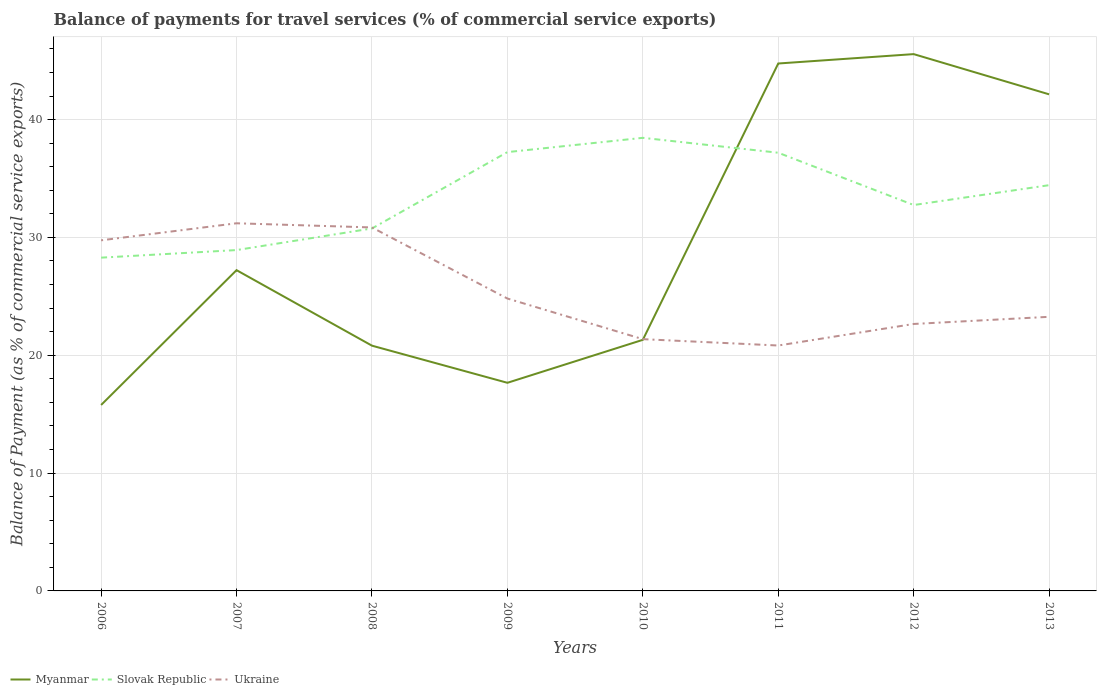Is the number of lines equal to the number of legend labels?
Offer a very short reply. Yes. Across all years, what is the maximum balance of payments for travel services in Myanmar?
Your answer should be very brief. 15.78. In which year was the balance of payments for travel services in Ukraine maximum?
Provide a succinct answer. 2011. What is the total balance of payments for travel services in Slovak Republic in the graph?
Your answer should be compact. -8.96. What is the difference between the highest and the second highest balance of payments for travel services in Myanmar?
Provide a succinct answer. 29.78. Is the balance of payments for travel services in Slovak Republic strictly greater than the balance of payments for travel services in Myanmar over the years?
Offer a very short reply. No. Are the values on the major ticks of Y-axis written in scientific E-notation?
Your answer should be very brief. No. Does the graph contain any zero values?
Give a very brief answer. No. Does the graph contain grids?
Make the answer very short. Yes. Where does the legend appear in the graph?
Give a very brief answer. Bottom left. How are the legend labels stacked?
Your answer should be compact. Horizontal. What is the title of the graph?
Ensure brevity in your answer.  Balance of payments for travel services (% of commercial service exports). What is the label or title of the X-axis?
Provide a short and direct response. Years. What is the label or title of the Y-axis?
Ensure brevity in your answer.  Balance of Payment (as % of commercial service exports). What is the Balance of Payment (as % of commercial service exports) in Myanmar in 2006?
Make the answer very short. 15.78. What is the Balance of Payment (as % of commercial service exports) of Slovak Republic in 2006?
Your response must be concise. 28.28. What is the Balance of Payment (as % of commercial service exports) of Ukraine in 2006?
Ensure brevity in your answer.  29.75. What is the Balance of Payment (as % of commercial service exports) of Myanmar in 2007?
Your response must be concise. 27.22. What is the Balance of Payment (as % of commercial service exports) in Slovak Republic in 2007?
Your answer should be compact. 28.93. What is the Balance of Payment (as % of commercial service exports) of Ukraine in 2007?
Give a very brief answer. 31.2. What is the Balance of Payment (as % of commercial service exports) in Myanmar in 2008?
Make the answer very short. 20.81. What is the Balance of Payment (as % of commercial service exports) in Slovak Republic in 2008?
Your answer should be compact. 30.76. What is the Balance of Payment (as % of commercial service exports) in Ukraine in 2008?
Provide a short and direct response. 30.85. What is the Balance of Payment (as % of commercial service exports) in Myanmar in 2009?
Make the answer very short. 17.66. What is the Balance of Payment (as % of commercial service exports) of Slovak Republic in 2009?
Provide a succinct answer. 37.24. What is the Balance of Payment (as % of commercial service exports) in Ukraine in 2009?
Provide a succinct answer. 24.81. What is the Balance of Payment (as % of commercial service exports) of Myanmar in 2010?
Your response must be concise. 21.31. What is the Balance of Payment (as % of commercial service exports) of Slovak Republic in 2010?
Give a very brief answer. 38.45. What is the Balance of Payment (as % of commercial service exports) of Ukraine in 2010?
Keep it short and to the point. 21.37. What is the Balance of Payment (as % of commercial service exports) of Myanmar in 2011?
Give a very brief answer. 44.76. What is the Balance of Payment (as % of commercial service exports) of Slovak Republic in 2011?
Give a very brief answer. 37.19. What is the Balance of Payment (as % of commercial service exports) in Ukraine in 2011?
Provide a short and direct response. 20.83. What is the Balance of Payment (as % of commercial service exports) in Myanmar in 2012?
Your answer should be very brief. 45.56. What is the Balance of Payment (as % of commercial service exports) of Slovak Republic in 2012?
Make the answer very short. 32.75. What is the Balance of Payment (as % of commercial service exports) of Ukraine in 2012?
Your answer should be compact. 22.65. What is the Balance of Payment (as % of commercial service exports) of Myanmar in 2013?
Give a very brief answer. 42.14. What is the Balance of Payment (as % of commercial service exports) of Slovak Republic in 2013?
Your answer should be very brief. 34.43. What is the Balance of Payment (as % of commercial service exports) of Ukraine in 2013?
Your answer should be very brief. 23.26. Across all years, what is the maximum Balance of Payment (as % of commercial service exports) of Myanmar?
Ensure brevity in your answer.  45.56. Across all years, what is the maximum Balance of Payment (as % of commercial service exports) of Slovak Republic?
Provide a succinct answer. 38.45. Across all years, what is the maximum Balance of Payment (as % of commercial service exports) in Ukraine?
Offer a terse response. 31.2. Across all years, what is the minimum Balance of Payment (as % of commercial service exports) in Myanmar?
Ensure brevity in your answer.  15.78. Across all years, what is the minimum Balance of Payment (as % of commercial service exports) of Slovak Republic?
Provide a short and direct response. 28.28. Across all years, what is the minimum Balance of Payment (as % of commercial service exports) in Ukraine?
Ensure brevity in your answer.  20.83. What is the total Balance of Payment (as % of commercial service exports) in Myanmar in the graph?
Make the answer very short. 235.24. What is the total Balance of Payment (as % of commercial service exports) in Slovak Republic in the graph?
Offer a very short reply. 268.03. What is the total Balance of Payment (as % of commercial service exports) in Ukraine in the graph?
Keep it short and to the point. 204.72. What is the difference between the Balance of Payment (as % of commercial service exports) of Myanmar in 2006 and that in 2007?
Your answer should be very brief. -11.44. What is the difference between the Balance of Payment (as % of commercial service exports) in Slovak Republic in 2006 and that in 2007?
Your answer should be very brief. -0.64. What is the difference between the Balance of Payment (as % of commercial service exports) of Ukraine in 2006 and that in 2007?
Ensure brevity in your answer.  -1.45. What is the difference between the Balance of Payment (as % of commercial service exports) in Myanmar in 2006 and that in 2008?
Keep it short and to the point. -5.03. What is the difference between the Balance of Payment (as % of commercial service exports) in Slovak Republic in 2006 and that in 2008?
Give a very brief answer. -2.48. What is the difference between the Balance of Payment (as % of commercial service exports) of Ukraine in 2006 and that in 2008?
Keep it short and to the point. -1.09. What is the difference between the Balance of Payment (as % of commercial service exports) of Myanmar in 2006 and that in 2009?
Make the answer very short. -1.88. What is the difference between the Balance of Payment (as % of commercial service exports) of Slovak Republic in 2006 and that in 2009?
Make the answer very short. -8.96. What is the difference between the Balance of Payment (as % of commercial service exports) in Ukraine in 2006 and that in 2009?
Give a very brief answer. 4.94. What is the difference between the Balance of Payment (as % of commercial service exports) of Myanmar in 2006 and that in 2010?
Provide a short and direct response. -5.53. What is the difference between the Balance of Payment (as % of commercial service exports) in Slovak Republic in 2006 and that in 2010?
Your answer should be very brief. -10.17. What is the difference between the Balance of Payment (as % of commercial service exports) in Ukraine in 2006 and that in 2010?
Your answer should be very brief. 8.39. What is the difference between the Balance of Payment (as % of commercial service exports) in Myanmar in 2006 and that in 2011?
Offer a very short reply. -28.98. What is the difference between the Balance of Payment (as % of commercial service exports) in Slovak Republic in 2006 and that in 2011?
Your answer should be compact. -8.9. What is the difference between the Balance of Payment (as % of commercial service exports) in Ukraine in 2006 and that in 2011?
Your answer should be very brief. 8.93. What is the difference between the Balance of Payment (as % of commercial service exports) of Myanmar in 2006 and that in 2012?
Provide a short and direct response. -29.78. What is the difference between the Balance of Payment (as % of commercial service exports) of Slovak Republic in 2006 and that in 2012?
Provide a short and direct response. -4.47. What is the difference between the Balance of Payment (as % of commercial service exports) of Ukraine in 2006 and that in 2012?
Give a very brief answer. 7.1. What is the difference between the Balance of Payment (as % of commercial service exports) in Myanmar in 2006 and that in 2013?
Your answer should be very brief. -26.36. What is the difference between the Balance of Payment (as % of commercial service exports) in Slovak Republic in 2006 and that in 2013?
Your answer should be compact. -6.15. What is the difference between the Balance of Payment (as % of commercial service exports) of Ukraine in 2006 and that in 2013?
Provide a succinct answer. 6.49. What is the difference between the Balance of Payment (as % of commercial service exports) of Myanmar in 2007 and that in 2008?
Provide a succinct answer. 6.41. What is the difference between the Balance of Payment (as % of commercial service exports) of Slovak Republic in 2007 and that in 2008?
Your answer should be compact. -1.83. What is the difference between the Balance of Payment (as % of commercial service exports) in Ukraine in 2007 and that in 2008?
Offer a terse response. 0.35. What is the difference between the Balance of Payment (as % of commercial service exports) of Myanmar in 2007 and that in 2009?
Your response must be concise. 9.56. What is the difference between the Balance of Payment (as % of commercial service exports) of Slovak Republic in 2007 and that in 2009?
Offer a very short reply. -8.31. What is the difference between the Balance of Payment (as % of commercial service exports) of Ukraine in 2007 and that in 2009?
Provide a succinct answer. 6.39. What is the difference between the Balance of Payment (as % of commercial service exports) of Myanmar in 2007 and that in 2010?
Make the answer very short. 5.91. What is the difference between the Balance of Payment (as % of commercial service exports) of Slovak Republic in 2007 and that in 2010?
Give a very brief answer. -9.53. What is the difference between the Balance of Payment (as % of commercial service exports) of Ukraine in 2007 and that in 2010?
Keep it short and to the point. 9.83. What is the difference between the Balance of Payment (as % of commercial service exports) of Myanmar in 2007 and that in 2011?
Provide a short and direct response. -17.54. What is the difference between the Balance of Payment (as % of commercial service exports) of Slovak Republic in 2007 and that in 2011?
Your answer should be very brief. -8.26. What is the difference between the Balance of Payment (as % of commercial service exports) in Ukraine in 2007 and that in 2011?
Ensure brevity in your answer.  10.37. What is the difference between the Balance of Payment (as % of commercial service exports) in Myanmar in 2007 and that in 2012?
Your answer should be compact. -18.33. What is the difference between the Balance of Payment (as % of commercial service exports) of Slovak Republic in 2007 and that in 2012?
Offer a terse response. -3.82. What is the difference between the Balance of Payment (as % of commercial service exports) of Ukraine in 2007 and that in 2012?
Provide a succinct answer. 8.55. What is the difference between the Balance of Payment (as % of commercial service exports) in Myanmar in 2007 and that in 2013?
Provide a succinct answer. -14.92. What is the difference between the Balance of Payment (as % of commercial service exports) of Slovak Republic in 2007 and that in 2013?
Keep it short and to the point. -5.51. What is the difference between the Balance of Payment (as % of commercial service exports) of Ukraine in 2007 and that in 2013?
Offer a terse response. 7.94. What is the difference between the Balance of Payment (as % of commercial service exports) of Myanmar in 2008 and that in 2009?
Ensure brevity in your answer.  3.15. What is the difference between the Balance of Payment (as % of commercial service exports) of Slovak Republic in 2008 and that in 2009?
Your response must be concise. -6.48. What is the difference between the Balance of Payment (as % of commercial service exports) in Ukraine in 2008 and that in 2009?
Ensure brevity in your answer.  6.03. What is the difference between the Balance of Payment (as % of commercial service exports) in Myanmar in 2008 and that in 2010?
Keep it short and to the point. -0.49. What is the difference between the Balance of Payment (as % of commercial service exports) of Slovak Republic in 2008 and that in 2010?
Offer a terse response. -7.69. What is the difference between the Balance of Payment (as % of commercial service exports) in Ukraine in 2008 and that in 2010?
Make the answer very short. 9.48. What is the difference between the Balance of Payment (as % of commercial service exports) of Myanmar in 2008 and that in 2011?
Keep it short and to the point. -23.95. What is the difference between the Balance of Payment (as % of commercial service exports) in Slovak Republic in 2008 and that in 2011?
Your response must be concise. -6.43. What is the difference between the Balance of Payment (as % of commercial service exports) in Ukraine in 2008 and that in 2011?
Your answer should be very brief. 10.02. What is the difference between the Balance of Payment (as % of commercial service exports) of Myanmar in 2008 and that in 2012?
Your response must be concise. -24.74. What is the difference between the Balance of Payment (as % of commercial service exports) of Slovak Republic in 2008 and that in 2012?
Give a very brief answer. -1.99. What is the difference between the Balance of Payment (as % of commercial service exports) in Ukraine in 2008 and that in 2012?
Ensure brevity in your answer.  8.19. What is the difference between the Balance of Payment (as % of commercial service exports) of Myanmar in 2008 and that in 2013?
Your response must be concise. -21.33. What is the difference between the Balance of Payment (as % of commercial service exports) of Slovak Republic in 2008 and that in 2013?
Offer a very short reply. -3.67. What is the difference between the Balance of Payment (as % of commercial service exports) in Ukraine in 2008 and that in 2013?
Give a very brief answer. 7.58. What is the difference between the Balance of Payment (as % of commercial service exports) of Myanmar in 2009 and that in 2010?
Give a very brief answer. -3.64. What is the difference between the Balance of Payment (as % of commercial service exports) in Slovak Republic in 2009 and that in 2010?
Your response must be concise. -1.21. What is the difference between the Balance of Payment (as % of commercial service exports) of Ukraine in 2009 and that in 2010?
Provide a short and direct response. 3.45. What is the difference between the Balance of Payment (as % of commercial service exports) in Myanmar in 2009 and that in 2011?
Give a very brief answer. -27.1. What is the difference between the Balance of Payment (as % of commercial service exports) of Slovak Republic in 2009 and that in 2011?
Your answer should be very brief. 0.05. What is the difference between the Balance of Payment (as % of commercial service exports) in Ukraine in 2009 and that in 2011?
Ensure brevity in your answer.  3.99. What is the difference between the Balance of Payment (as % of commercial service exports) in Myanmar in 2009 and that in 2012?
Your response must be concise. -27.89. What is the difference between the Balance of Payment (as % of commercial service exports) in Slovak Republic in 2009 and that in 2012?
Offer a terse response. 4.49. What is the difference between the Balance of Payment (as % of commercial service exports) in Ukraine in 2009 and that in 2012?
Provide a succinct answer. 2.16. What is the difference between the Balance of Payment (as % of commercial service exports) of Myanmar in 2009 and that in 2013?
Keep it short and to the point. -24.48. What is the difference between the Balance of Payment (as % of commercial service exports) of Slovak Republic in 2009 and that in 2013?
Provide a succinct answer. 2.81. What is the difference between the Balance of Payment (as % of commercial service exports) in Ukraine in 2009 and that in 2013?
Your response must be concise. 1.55. What is the difference between the Balance of Payment (as % of commercial service exports) of Myanmar in 2010 and that in 2011?
Provide a succinct answer. -23.45. What is the difference between the Balance of Payment (as % of commercial service exports) of Slovak Republic in 2010 and that in 2011?
Your answer should be very brief. 1.26. What is the difference between the Balance of Payment (as % of commercial service exports) in Ukraine in 2010 and that in 2011?
Make the answer very short. 0.54. What is the difference between the Balance of Payment (as % of commercial service exports) of Myanmar in 2010 and that in 2012?
Your answer should be compact. -24.25. What is the difference between the Balance of Payment (as % of commercial service exports) in Slovak Republic in 2010 and that in 2012?
Your answer should be compact. 5.7. What is the difference between the Balance of Payment (as % of commercial service exports) in Ukraine in 2010 and that in 2012?
Offer a very short reply. -1.29. What is the difference between the Balance of Payment (as % of commercial service exports) in Myanmar in 2010 and that in 2013?
Offer a very short reply. -20.84. What is the difference between the Balance of Payment (as % of commercial service exports) of Slovak Republic in 2010 and that in 2013?
Offer a very short reply. 4.02. What is the difference between the Balance of Payment (as % of commercial service exports) in Ukraine in 2010 and that in 2013?
Make the answer very short. -1.9. What is the difference between the Balance of Payment (as % of commercial service exports) of Myanmar in 2011 and that in 2012?
Your response must be concise. -0.8. What is the difference between the Balance of Payment (as % of commercial service exports) of Slovak Republic in 2011 and that in 2012?
Your response must be concise. 4.44. What is the difference between the Balance of Payment (as % of commercial service exports) in Ukraine in 2011 and that in 2012?
Your answer should be very brief. -1.83. What is the difference between the Balance of Payment (as % of commercial service exports) in Myanmar in 2011 and that in 2013?
Provide a succinct answer. 2.62. What is the difference between the Balance of Payment (as % of commercial service exports) in Slovak Republic in 2011 and that in 2013?
Make the answer very short. 2.75. What is the difference between the Balance of Payment (as % of commercial service exports) of Ukraine in 2011 and that in 2013?
Your answer should be compact. -2.44. What is the difference between the Balance of Payment (as % of commercial service exports) of Myanmar in 2012 and that in 2013?
Ensure brevity in your answer.  3.41. What is the difference between the Balance of Payment (as % of commercial service exports) of Slovak Republic in 2012 and that in 2013?
Provide a succinct answer. -1.68. What is the difference between the Balance of Payment (as % of commercial service exports) in Ukraine in 2012 and that in 2013?
Make the answer very short. -0.61. What is the difference between the Balance of Payment (as % of commercial service exports) of Myanmar in 2006 and the Balance of Payment (as % of commercial service exports) of Slovak Republic in 2007?
Keep it short and to the point. -13.15. What is the difference between the Balance of Payment (as % of commercial service exports) of Myanmar in 2006 and the Balance of Payment (as % of commercial service exports) of Ukraine in 2007?
Provide a short and direct response. -15.42. What is the difference between the Balance of Payment (as % of commercial service exports) in Slovak Republic in 2006 and the Balance of Payment (as % of commercial service exports) in Ukraine in 2007?
Ensure brevity in your answer.  -2.92. What is the difference between the Balance of Payment (as % of commercial service exports) in Myanmar in 2006 and the Balance of Payment (as % of commercial service exports) in Slovak Republic in 2008?
Keep it short and to the point. -14.98. What is the difference between the Balance of Payment (as % of commercial service exports) of Myanmar in 2006 and the Balance of Payment (as % of commercial service exports) of Ukraine in 2008?
Offer a very short reply. -15.07. What is the difference between the Balance of Payment (as % of commercial service exports) in Slovak Republic in 2006 and the Balance of Payment (as % of commercial service exports) in Ukraine in 2008?
Your answer should be very brief. -2.56. What is the difference between the Balance of Payment (as % of commercial service exports) in Myanmar in 2006 and the Balance of Payment (as % of commercial service exports) in Slovak Republic in 2009?
Your response must be concise. -21.46. What is the difference between the Balance of Payment (as % of commercial service exports) of Myanmar in 2006 and the Balance of Payment (as % of commercial service exports) of Ukraine in 2009?
Your answer should be very brief. -9.04. What is the difference between the Balance of Payment (as % of commercial service exports) in Slovak Republic in 2006 and the Balance of Payment (as % of commercial service exports) in Ukraine in 2009?
Your response must be concise. 3.47. What is the difference between the Balance of Payment (as % of commercial service exports) of Myanmar in 2006 and the Balance of Payment (as % of commercial service exports) of Slovak Republic in 2010?
Your answer should be very brief. -22.67. What is the difference between the Balance of Payment (as % of commercial service exports) of Myanmar in 2006 and the Balance of Payment (as % of commercial service exports) of Ukraine in 2010?
Your response must be concise. -5.59. What is the difference between the Balance of Payment (as % of commercial service exports) of Slovak Republic in 2006 and the Balance of Payment (as % of commercial service exports) of Ukraine in 2010?
Provide a succinct answer. 6.92. What is the difference between the Balance of Payment (as % of commercial service exports) of Myanmar in 2006 and the Balance of Payment (as % of commercial service exports) of Slovak Republic in 2011?
Keep it short and to the point. -21.41. What is the difference between the Balance of Payment (as % of commercial service exports) of Myanmar in 2006 and the Balance of Payment (as % of commercial service exports) of Ukraine in 2011?
Your response must be concise. -5.05. What is the difference between the Balance of Payment (as % of commercial service exports) of Slovak Republic in 2006 and the Balance of Payment (as % of commercial service exports) of Ukraine in 2011?
Provide a short and direct response. 7.46. What is the difference between the Balance of Payment (as % of commercial service exports) of Myanmar in 2006 and the Balance of Payment (as % of commercial service exports) of Slovak Republic in 2012?
Your answer should be compact. -16.97. What is the difference between the Balance of Payment (as % of commercial service exports) of Myanmar in 2006 and the Balance of Payment (as % of commercial service exports) of Ukraine in 2012?
Your answer should be compact. -6.88. What is the difference between the Balance of Payment (as % of commercial service exports) in Slovak Republic in 2006 and the Balance of Payment (as % of commercial service exports) in Ukraine in 2012?
Your answer should be compact. 5.63. What is the difference between the Balance of Payment (as % of commercial service exports) in Myanmar in 2006 and the Balance of Payment (as % of commercial service exports) in Slovak Republic in 2013?
Provide a succinct answer. -18.65. What is the difference between the Balance of Payment (as % of commercial service exports) of Myanmar in 2006 and the Balance of Payment (as % of commercial service exports) of Ukraine in 2013?
Your answer should be very brief. -7.48. What is the difference between the Balance of Payment (as % of commercial service exports) in Slovak Republic in 2006 and the Balance of Payment (as % of commercial service exports) in Ukraine in 2013?
Ensure brevity in your answer.  5.02. What is the difference between the Balance of Payment (as % of commercial service exports) in Myanmar in 2007 and the Balance of Payment (as % of commercial service exports) in Slovak Republic in 2008?
Make the answer very short. -3.54. What is the difference between the Balance of Payment (as % of commercial service exports) of Myanmar in 2007 and the Balance of Payment (as % of commercial service exports) of Ukraine in 2008?
Give a very brief answer. -3.63. What is the difference between the Balance of Payment (as % of commercial service exports) of Slovak Republic in 2007 and the Balance of Payment (as % of commercial service exports) of Ukraine in 2008?
Make the answer very short. -1.92. What is the difference between the Balance of Payment (as % of commercial service exports) of Myanmar in 2007 and the Balance of Payment (as % of commercial service exports) of Slovak Republic in 2009?
Make the answer very short. -10.02. What is the difference between the Balance of Payment (as % of commercial service exports) in Myanmar in 2007 and the Balance of Payment (as % of commercial service exports) in Ukraine in 2009?
Offer a terse response. 2.41. What is the difference between the Balance of Payment (as % of commercial service exports) in Slovak Republic in 2007 and the Balance of Payment (as % of commercial service exports) in Ukraine in 2009?
Offer a terse response. 4.11. What is the difference between the Balance of Payment (as % of commercial service exports) in Myanmar in 2007 and the Balance of Payment (as % of commercial service exports) in Slovak Republic in 2010?
Your response must be concise. -11.23. What is the difference between the Balance of Payment (as % of commercial service exports) of Myanmar in 2007 and the Balance of Payment (as % of commercial service exports) of Ukraine in 2010?
Make the answer very short. 5.86. What is the difference between the Balance of Payment (as % of commercial service exports) of Slovak Republic in 2007 and the Balance of Payment (as % of commercial service exports) of Ukraine in 2010?
Your response must be concise. 7.56. What is the difference between the Balance of Payment (as % of commercial service exports) in Myanmar in 2007 and the Balance of Payment (as % of commercial service exports) in Slovak Republic in 2011?
Offer a terse response. -9.97. What is the difference between the Balance of Payment (as % of commercial service exports) of Myanmar in 2007 and the Balance of Payment (as % of commercial service exports) of Ukraine in 2011?
Keep it short and to the point. 6.39. What is the difference between the Balance of Payment (as % of commercial service exports) of Slovak Republic in 2007 and the Balance of Payment (as % of commercial service exports) of Ukraine in 2011?
Give a very brief answer. 8.1. What is the difference between the Balance of Payment (as % of commercial service exports) in Myanmar in 2007 and the Balance of Payment (as % of commercial service exports) in Slovak Republic in 2012?
Give a very brief answer. -5.53. What is the difference between the Balance of Payment (as % of commercial service exports) in Myanmar in 2007 and the Balance of Payment (as % of commercial service exports) in Ukraine in 2012?
Offer a very short reply. 4.57. What is the difference between the Balance of Payment (as % of commercial service exports) in Slovak Republic in 2007 and the Balance of Payment (as % of commercial service exports) in Ukraine in 2012?
Provide a short and direct response. 6.27. What is the difference between the Balance of Payment (as % of commercial service exports) of Myanmar in 2007 and the Balance of Payment (as % of commercial service exports) of Slovak Republic in 2013?
Keep it short and to the point. -7.21. What is the difference between the Balance of Payment (as % of commercial service exports) of Myanmar in 2007 and the Balance of Payment (as % of commercial service exports) of Ukraine in 2013?
Your response must be concise. 3.96. What is the difference between the Balance of Payment (as % of commercial service exports) in Slovak Republic in 2007 and the Balance of Payment (as % of commercial service exports) in Ukraine in 2013?
Provide a succinct answer. 5.66. What is the difference between the Balance of Payment (as % of commercial service exports) in Myanmar in 2008 and the Balance of Payment (as % of commercial service exports) in Slovak Republic in 2009?
Give a very brief answer. -16.43. What is the difference between the Balance of Payment (as % of commercial service exports) in Myanmar in 2008 and the Balance of Payment (as % of commercial service exports) in Ukraine in 2009?
Provide a succinct answer. -4. What is the difference between the Balance of Payment (as % of commercial service exports) of Slovak Republic in 2008 and the Balance of Payment (as % of commercial service exports) of Ukraine in 2009?
Make the answer very short. 5.95. What is the difference between the Balance of Payment (as % of commercial service exports) of Myanmar in 2008 and the Balance of Payment (as % of commercial service exports) of Slovak Republic in 2010?
Provide a succinct answer. -17.64. What is the difference between the Balance of Payment (as % of commercial service exports) in Myanmar in 2008 and the Balance of Payment (as % of commercial service exports) in Ukraine in 2010?
Your response must be concise. -0.55. What is the difference between the Balance of Payment (as % of commercial service exports) in Slovak Republic in 2008 and the Balance of Payment (as % of commercial service exports) in Ukraine in 2010?
Give a very brief answer. 9.39. What is the difference between the Balance of Payment (as % of commercial service exports) of Myanmar in 2008 and the Balance of Payment (as % of commercial service exports) of Slovak Republic in 2011?
Provide a succinct answer. -16.37. What is the difference between the Balance of Payment (as % of commercial service exports) in Myanmar in 2008 and the Balance of Payment (as % of commercial service exports) in Ukraine in 2011?
Your answer should be very brief. -0.01. What is the difference between the Balance of Payment (as % of commercial service exports) of Slovak Republic in 2008 and the Balance of Payment (as % of commercial service exports) of Ukraine in 2011?
Provide a short and direct response. 9.93. What is the difference between the Balance of Payment (as % of commercial service exports) of Myanmar in 2008 and the Balance of Payment (as % of commercial service exports) of Slovak Republic in 2012?
Make the answer very short. -11.94. What is the difference between the Balance of Payment (as % of commercial service exports) of Myanmar in 2008 and the Balance of Payment (as % of commercial service exports) of Ukraine in 2012?
Your answer should be compact. -1.84. What is the difference between the Balance of Payment (as % of commercial service exports) of Slovak Republic in 2008 and the Balance of Payment (as % of commercial service exports) of Ukraine in 2012?
Keep it short and to the point. 8.1. What is the difference between the Balance of Payment (as % of commercial service exports) in Myanmar in 2008 and the Balance of Payment (as % of commercial service exports) in Slovak Republic in 2013?
Provide a short and direct response. -13.62. What is the difference between the Balance of Payment (as % of commercial service exports) of Myanmar in 2008 and the Balance of Payment (as % of commercial service exports) of Ukraine in 2013?
Your response must be concise. -2.45. What is the difference between the Balance of Payment (as % of commercial service exports) in Slovak Republic in 2008 and the Balance of Payment (as % of commercial service exports) in Ukraine in 2013?
Provide a short and direct response. 7.5. What is the difference between the Balance of Payment (as % of commercial service exports) in Myanmar in 2009 and the Balance of Payment (as % of commercial service exports) in Slovak Republic in 2010?
Your answer should be very brief. -20.79. What is the difference between the Balance of Payment (as % of commercial service exports) in Myanmar in 2009 and the Balance of Payment (as % of commercial service exports) in Ukraine in 2010?
Offer a terse response. -3.7. What is the difference between the Balance of Payment (as % of commercial service exports) of Slovak Republic in 2009 and the Balance of Payment (as % of commercial service exports) of Ukraine in 2010?
Your response must be concise. 15.87. What is the difference between the Balance of Payment (as % of commercial service exports) in Myanmar in 2009 and the Balance of Payment (as % of commercial service exports) in Slovak Republic in 2011?
Ensure brevity in your answer.  -19.52. What is the difference between the Balance of Payment (as % of commercial service exports) of Myanmar in 2009 and the Balance of Payment (as % of commercial service exports) of Ukraine in 2011?
Your answer should be very brief. -3.16. What is the difference between the Balance of Payment (as % of commercial service exports) in Slovak Republic in 2009 and the Balance of Payment (as % of commercial service exports) in Ukraine in 2011?
Provide a short and direct response. 16.41. What is the difference between the Balance of Payment (as % of commercial service exports) in Myanmar in 2009 and the Balance of Payment (as % of commercial service exports) in Slovak Republic in 2012?
Your answer should be very brief. -15.09. What is the difference between the Balance of Payment (as % of commercial service exports) in Myanmar in 2009 and the Balance of Payment (as % of commercial service exports) in Ukraine in 2012?
Keep it short and to the point. -4.99. What is the difference between the Balance of Payment (as % of commercial service exports) in Slovak Republic in 2009 and the Balance of Payment (as % of commercial service exports) in Ukraine in 2012?
Your response must be concise. 14.59. What is the difference between the Balance of Payment (as % of commercial service exports) in Myanmar in 2009 and the Balance of Payment (as % of commercial service exports) in Slovak Republic in 2013?
Your answer should be very brief. -16.77. What is the difference between the Balance of Payment (as % of commercial service exports) of Myanmar in 2009 and the Balance of Payment (as % of commercial service exports) of Ukraine in 2013?
Give a very brief answer. -5.6. What is the difference between the Balance of Payment (as % of commercial service exports) in Slovak Republic in 2009 and the Balance of Payment (as % of commercial service exports) in Ukraine in 2013?
Ensure brevity in your answer.  13.98. What is the difference between the Balance of Payment (as % of commercial service exports) of Myanmar in 2010 and the Balance of Payment (as % of commercial service exports) of Slovak Republic in 2011?
Your answer should be compact. -15.88. What is the difference between the Balance of Payment (as % of commercial service exports) of Myanmar in 2010 and the Balance of Payment (as % of commercial service exports) of Ukraine in 2011?
Provide a succinct answer. 0.48. What is the difference between the Balance of Payment (as % of commercial service exports) of Slovak Republic in 2010 and the Balance of Payment (as % of commercial service exports) of Ukraine in 2011?
Your response must be concise. 17.63. What is the difference between the Balance of Payment (as % of commercial service exports) of Myanmar in 2010 and the Balance of Payment (as % of commercial service exports) of Slovak Republic in 2012?
Give a very brief answer. -11.44. What is the difference between the Balance of Payment (as % of commercial service exports) of Myanmar in 2010 and the Balance of Payment (as % of commercial service exports) of Ukraine in 2012?
Make the answer very short. -1.35. What is the difference between the Balance of Payment (as % of commercial service exports) of Slovak Republic in 2010 and the Balance of Payment (as % of commercial service exports) of Ukraine in 2012?
Offer a terse response. 15.8. What is the difference between the Balance of Payment (as % of commercial service exports) in Myanmar in 2010 and the Balance of Payment (as % of commercial service exports) in Slovak Republic in 2013?
Offer a very short reply. -13.13. What is the difference between the Balance of Payment (as % of commercial service exports) of Myanmar in 2010 and the Balance of Payment (as % of commercial service exports) of Ukraine in 2013?
Your response must be concise. -1.95. What is the difference between the Balance of Payment (as % of commercial service exports) in Slovak Republic in 2010 and the Balance of Payment (as % of commercial service exports) in Ukraine in 2013?
Provide a short and direct response. 15.19. What is the difference between the Balance of Payment (as % of commercial service exports) of Myanmar in 2011 and the Balance of Payment (as % of commercial service exports) of Slovak Republic in 2012?
Make the answer very short. 12.01. What is the difference between the Balance of Payment (as % of commercial service exports) in Myanmar in 2011 and the Balance of Payment (as % of commercial service exports) in Ukraine in 2012?
Provide a succinct answer. 22.11. What is the difference between the Balance of Payment (as % of commercial service exports) in Slovak Republic in 2011 and the Balance of Payment (as % of commercial service exports) in Ukraine in 2012?
Offer a terse response. 14.53. What is the difference between the Balance of Payment (as % of commercial service exports) in Myanmar in 2011 and the Balance of Payment (as % of commercial service exports) in Slovak Republic in 2013?
Give a very brief answer. 10.33. What is the difference between the Balance of Payment (as % of commercial service exports) of Myanmar in 2011 and the Balance of Payment (as % of commercial service exports) of Ukraine in 2013?
Make the answer very short. 21.5. What is the difference between the Balance of Payment (as % of commercial service exports) in Slovak Republic in 2011 and the Balance of Payment (as % of commercial service exports) in Ukraine in 2013?
Give a very brief answer. 13.92. What is the difference between the Balance of Payment (as % of commercial service exports) of Myanmar in 2012 and the Balance of Payment (as % of commercial service exports) of Slovak Republic in 2013?
Your answer should be very brief. 11.12. What is the difference between the Balance of Payment (as % of commercial service exports) in Myanmar in 2012 and the Balance of Payment (as % of commercial service exports) in Ukraine in 2013?
Offer a very short reply. 22.29. What is the difference between the Balance of Payment (as % of commercial service exports) in Slovak Republic in 2012 and the Balance of Payment (as % of commercial service exports) in Ukraine in 2013?
Keep it short and to the point. 9.49. What is the average Balance of Payment (as % of commercial service exports) in Myanmar per year?
Offer a very short reply. 29.41. What is the average Balance of Payment (as % of commercial service exports) of Slovak Republic per year?
Offer a terse response. 33.5. What is the average Balance of Payment (as % of commercial service exports) of Ukraine per year?
Keep it short and to the point. 25.59. In the year 2006, what is the difference between the Balance of Payment (as % of commercial service exports) in Myanmar and Balance of Payment (as % of commercial service exports) in Slovak Republic?
Make the answer very short. -12.5. In the year 2006, what is the difference between the Balance of Payment (as % of commercial service exports) in Myanmar and Balance of Payment (as % of commercial service exports) in Ukraine?
Make the answer very short. -13.97. In the year 2006, what is the difference between the Balance of Payment (as % of commercial service exports) in Slovak Republic and Balance of Payment (as % of commercial service exports) in Ukraine?
Offer a terse response. -1.47. In the year 2007, what is the difference between the Balance of Payment (as % of commercial service exports) in Myanmar and Balance of Payment (as % of commercial service exports) in Slovak Republic?
Ensure brevity in your answer.  -1.71. In the year 2007, what is the difference between the Balance of Payment (as % of commercial service exports) of Myanmar and Balance of Payment (as % of commercial service exports) of Ukraine?
Offer a terse response. -3.98. In the year 2007, what is the difference between the Balance of Payment (as % of commercial service exports) of Slovak Republic and Balance of Payment (as % of commercial service exports) of Ukraine?
Your answer should be compact. -2.27. In the year 2008, what is the difference between the Balance of Payment (as % of commercial service exports) of Myanmar and Balance of Payment (as % of commercial service exports) of Slovak Republic?
Give a very brief answer. -9.95. In the year 2008, what is the difference between the Balance of Payment (as % of commercial service exports) in Myanmar and Balance of Payment (as % of commercial service exports) in Ukraine?
Your answer should be very brief. -10.03. In the year 2008, what is the difference between the Balance of Payment (as % of commercial service exports) of Slovak Republic and Balance of Payment (as % of commercial service exports) of Ukraine?
Make the answer very short. -0.09. In the year 2009, what is the difference between the Balance of Payment (as % of commercial service exports) of Myanmar and Balance of Payment (as % of commercial service exports) of Slovak Republic?
Offer a very short reply. -19.58. In the year 2009, what is the difference between the Balance of Payment (as % of commercial service exports) in Myanmar and Balance of Payment (as % of commercial service exports) in Ukraine?
Your response must be concise. -7.15. In the year 2009, what is the difference between the Balance of Payment (as % of commercial service exports) in Slovak Republic and Balance of Payment (as % of commercial service exports) in Ukraine?
Your answer should be very brief. 12.43. In the year 2010, what is the difference between the Balance of Payment (as % of commercial service exports) of Myanmar and Balance of Payment (as % of commercial service exports) of Slovak Republic?
Offer a very short reply. -17.14. In the year 2010, what is the difference between the Balance of Payment (as % of commercial service exports) in Myanmar and Balance of Payment (as % of commercial service exports) in Ukraine?
Your answer should be compact. -0.06. In the year 2010, what is the difference between the Balance of Payment (as % of commercial service exports) of Slovak Republic and Balance of Payment (as % of commercial service exports) of Ukraine?
Keep it short and to the point. 17.09. In the year 2011, what is the difference between the Balance of Payment (as % of commercial service exports) in Myanmar and Balance of Payment (as % of commercial service exports) in Slovak Republic?
Provide a short and direct response. 7.57. In the year 2011, what is the difference between the Balance of Payment (as % of commercial service exports) of Myanmar and Balance of Payment (as % of commercial service exports) of Ukraine?
Offer a very short reply. 23.93. In the year 2011, what is the difference between the Balance of Payment (as % of commercial service exports) in Slovak Republic and Balance of Payment (as % of commercial service exports) in Ukraine?
Provide a succinct answer. 16.36. In the year 2012, what is the difference between the Balance of Payment (as % of commercial service exports) of Myanmar and Balance of Payment (as % of commercial service exports) of Slovak Republic?
Ensure brevity in your answer.  12.81. In the year 2012, what is the difference between the Balance of Payment (as % of commercial service exports) in Myanmar and Balance of Payment (as % of commercial service exports) in Ukraine?
Offer a terse response. 22.9. In the year 2012, what is the difference between the Balance of Payment (as % of commercial service exports) of Slovak Republic and Balance of Payment (as % of commercial service exports) of Ukraine?
Ensure brevity in your answer.  10.09. In the year 2013, what is the difference between the Balance of Payment (as % of commercial service exports) of Myanmar and Balance of Payment (as % of commercial service exports) of Slovak Republic?
Your answer should be compact. 7.71. In the year 2013, what is the difference between the Balance of Payment (as % of commercial service exports) of Myanmar and Balance of Payment (as % of commercial service exports) of Ukraine?
Make the answer very short. 18.88. In the year 2013, what is the difference between the Balance of Payment (as % of commercial service exports) in Slovak Republic and Balance of Payment (as % of commercial service exports) in Ukraine?
Offer a very short reply. 11.17. What is the ratio of the Balance of Payment (as % of commercial service exports) of Myanmar in 2006 to that in 2007?
Provide a short and direct response. 0.58. What is the ratio of the Balance of Payment (as % of commercial service exports) of Slovak Republic in 2006 to that in 2007?
Make the answer very short. 0.98. What is the ratio of the Balance of Payment (as % of commercial service exports) in Ukraine in 2006 to that in 2007?
Your response must be concise. 0.95. What is the ratio of the Balance of Payment (as % of commercial service exports) in Myanmar in 2006 to that in 2008?
Offer a terse response. 0.76. What is the ratio of the Balance of Payment (as % of commercial service exports) of Slovak Republic in 2006 to that in 2008?
Give a very brief answer. 0.92. What is the ratio of the Balance of Payment (as % of commercial service exports) of Ukraine in 2006 to that in 2008?
Your answer should be very brief. 0.96. What is the ratio of the Balance of Payment (as % of commercial service exports) of Myanmar in 2006 to that in 2009?
Offer a very short reply. 0.89. What is the ratio of the Balance of Payment (as % of commercial service exports) in Slovak Republic in 2006 to that in 2009?
Give a very brief answer. 0.76. What is the ratio of the Balance of Payment (as % of commercial service exports) in Ukraine in 2006 to that in 2009?
Offer a very short reply. 1.2. What is the ratio of the Balance of Payment (as % of commercial service exports) of Myanmar in 2006 to that in 2010?
Provide a succinct answer. 0.74. What is the ratio of the Balance of Payment (as % of commercial service exports) in Slovak Republic in 2006 to that in 2010?
Ensure brevity in your answer.  0.74. What is the ratio of the Balance of Payment (as % of commercial service exports) of Ukraine in 2006 to that in 2010?
Offer a terse response. 1.39. What is the ratio of the Balance of Payment (as % of commercial service exports) in Myanmar in 2006 to that in 2011?
Provide a succinct answer. 0.35. What is the ratio of the Balance of Payment (as % of commercial service exports) of Slovak Republic in 2006 to that in 2011?
Provide a short and direct response. 0.76. What is the ratio of the Balance of Payment (as % of commercial service exports) of Ukraine in 2006 to that in 2011?
Your answer should be compact. 1.43. What is the ratio of the Balance of Payment (as % of commercial service exports) of Myanmar in 2006 to that in 2012?
Provide a succinct answer. 0.35. What is the ratio of the Balance of Payment (as % of commercial service exports) in Slovak Republic in 2006 to that in 2012?
Give a very brief answer. 0.86. What is the ratio of the Balance of Payment (as % of commercial service exports) in Ukraine in 2006 to that in 2012?
Offer a terse response. 1.31. What is the ratio of the Balance of Payment (as % of commercial service exports) of Myanmar in 2006 to that in 2013?
Keep it short and to the point. 0.37. What is the ratio of the Balance of Payment (as % of commercial service exports) of Slovak Republic in 2006 to that in 2013?
Ensure brevity in your answer.  0.82. What is the ratio of the Balance of Payment (as % of commercial service exports) of Ukraine in 2006 to that in 2013?
Your answer should be very brief. 1.28. What is the ratio of the Balance of Payment (as % of commercial service exports) in Myanmar in 2007 to that in 2008?
Offer a very short reply. 1.31. What is the ratio of the Balance of Payment (as % of commercial service exports) of Slovak Republic in 2007 to that in 2008?
Make the answer very short. 0.94. What is the ratio of the Balance of Payment (as % of commercial service exports) of Ukraine in 2007 to that in 2008?
Ensure brevity in your answer.  1.01. What is the ratio of the Balance of Payment (as % of commercial service exports) of Myanmar in 2007 to that in 2009?
Your answer should be compact. 1.54. What is the ratio of the Balance of Payment (as % of commercial service exports) in Slovak Republic in 2007 to that in 2009?
Make the answer very short. 0.78. What is the ratio of the Balance of Payment (as % of commercial service exports) of Ukraine in 2007 to that in 2009?
Offer a very short reply. 1.26. What is the ratio of the Balance of Payment (as % of commercial service exports) of Myanmar in 2007 to that in 2010?
Ensure brevity in your answer.  1.28. What is the ratio of the Balance of Payment (as % of commercial service exports) of Slovak Republic in 2007 to that in 2010?
Your answer should be compact. 0.75. What is the ratio of the Balance of Payment (as % of commercial service exports) of Ukraine in 2007 to that in 2010?
Offer a terse response. 1.46. What is the ratio of the Balance of Payment (as % of commercial service exports) of Myanmar in 2007 to that in 2011?
Offer a very short reply. 0.61. What is the ratio of the Balance of Payment (as % of commercial service exports) of Slovak Republic in 2007 to that in 2011?
Offer a terse response. 0.78. What is the ratio of the Balance of Payment (as % of commercial service exports) of Ukraine in 2007 to that in 2011?
Ensure brevity in your answer.  1.5. What is the ratio of the Balance of Payment (as % of commercial service exports) of Myanmar in 2007 to that in 2012?
Offer a terse response. 0.6. What is the ratio of the Balance of Payment (as % of commercial service exports) of Slovak Republic in 2007 to that in 2012?
Your response must be concise. 0.88. What is the ratio of the Balance of Payment (as % of commercial service exports) in Ukraine in 2007 to that in 2012?
Ensure brevity in your answer.  1.38. What is the ratio of the Balance of Payment (as % of commercial service exports) of Myanmar in 2007 to that in 2013?
Offer a terse response. 0.65. What is the ratio of the Balance of Payment (as % of commercial service exports) in Slovak Republic in 2007 to that in 2013?
Give a very brief answer. 0.84. What is the ratio of the Balance of Payment (as % of commercial service exports) of Ukraine in 2007 to that in 2013?
Make the answer very short. 1.34. What is the ratio of the Balance of Payment (as % of commercial service exports) in Myanmar in 2008 to that in 2009?
Offer a terse response. 1.18. What is the ratio of the Balance of Payment (as % of commercial service exports) of Slovak Republic in 2008 to that in 2009?
Your answer should be very brief. 0.83. What is the ratio of the Balance of Payment (as % of commercial service exports) in Ukraine in 2008 to that in 2009?
Your response must be concise. 1.24. What is the ratio of the Balance of Payment (as % of commercial service exports) in Myanmar in 2008 to that in 2010?
Offer a very short reply. 0.98. What is the ratio of the Balance of Payment (as % of commercial service exports) in Ukraine in 2008 to that in 2010?
Offer a terse response. 1.44. What is the ratio of the Balance of Payment (as % of commercial service exports) of Myanmar in 2008 to that in 2011?
Give a very brief answer. 0.47. What is the ratio of the Balance of Payment (as % of commercial service exports) of Slovak Republic in 2008 to that in 2011?
Provide a succinct answer. 0.83. What is the ratio of the Balance of Payment (as % of commercial service exports) in Ukraine in 2008 to that in 2011?
Give a very brief answer. 1.48. What is the ratio of the Balance of Payment (as % of commercial service exports) in Myanmar in 2008 to that in 2012?
Your answer should be compact. 0.46. What is the ratio of the Balance of Payment (as % of commercial service exports) in Slovak Republic in 2008 to that in 2012?
Offer a very short reply. 0.94. What is the ratio of the Balance of Payment (as % of commercial service exports) of Ukraine in 2008 to that in 2012?
Keep it short and to the point. 1.36. What is the ratio of the Balance of Payment (as % of commercial service exports) of Myanmar in 2008 to that in 2013?
Your response must be concise. 0.49. What is the ratio of the Balance of Payment (as % of commercial service exports) of Slovak Republic in 2008 to that in 2013?
Give a very brief answer. 0.89. What is the ratio of the Balance of Payment (as % of commercial service exports) in Ukraine in 2008 to that in 2013?
Offer a very short reply. 1.33. What is the ratio of the Balance of Payment (as % of commercial service exports) in Myanmar in 2009 to that in 2010?
Give a very brief answer. 0.83. What is the ratio of the Balance of Payment (as % of commercial service exports) of Slovak Republic in 2009 to that in 2010?
Your answer should be very brief. 0.97. What is the ratio of the Balance of Payment (as % of commercial service exports) of Ukraine in 2009 to that in 2010?
Provide a succinct answer. 1.16. What is the ratio of the Balance of Payment (as % of commercial service exports) of Myanmar in 2009 to that in 2011?
Your answer should be very brief. 0.39. What is the ratio of the Balance of Payment (as % of commercial service exports) of Ukraine in 2009 to that in 2011?
Provide a succinct answer. 1.19. What is the ratio of the Balance of Payment (as % of commercial service exports) of Myanmar in 2009 to that in 2012?
Your answer should be compact. 0.39. What is the ratio of the Balance of Payment (as % of commercial service exports) of Slovak Republic in 2009 to that in 2012?
Offer a terse response. 1.14. What is the ratio of the Balance of Payment (as % of commercial service exports) in Ukraine in 2009 to that in 2012?
Your answer should be compact. 1.1. What is the ratio of the Balance of Payment (as % of commercial service exports) of Myanmar in 2009 to that in 2013?
Give a very brief answer. 0.42. What is the ratio of the Balance of Payment (as % of commercial service exports) of Slovak Republic in 2009 to that in 2013?
Your answer should be compact. 1.08. What is the ratio of the Balance of Payment (as % of commercial service exports) in Ukraine in 2009 to that in 2013?
Offer a terse response. 1.07. What is the ratio of the Balance of Payment (as % of commercial service exports) of Myanmar in 2010 to that in 2011?
Offer a terse response. 0.48. What is the ratio of the Balance of Payment (as % of commercial service exports) in Slovak Republic in 2010 to that in 2011?
Offer a terse response. 1.03. What is the ratio of the Balance of Payment (as % of commercial service exports) in Ukraine in 2010 to that in 2011?
Your answer should be very brief. 1.03. What is the ratio of the Balance of Payment (as % of commercial service exports) in Myanmar in 2010 to that in 2012?
Provide a succinct answer. 0.47. What is the ratio of the Balance of Payment (as % of commercial service exports) in Slovak Republic in 2010 to that in 2012?
Keep it short and to the point. 1.17. What is the ratio of the Balance of Payment (as % of commercial service exports) of Ukraine in 2010 to that in 2012?
Make the answer very short. 0.94. What is the ratio of the Balance of Payment (as % of commercial service exports) of Myanmar in 2010 to that in 2013?
Offer a very short reply. 0.51. What is the ratio of the Balance of Payment (as % of commercial service exports) of Slovak Republic in 2010 to that in 2013?
Your answer should be very brief. 1.12. What is the ratio of the Balance of Payment (as % of commercial service exports) in Ukraine in 2010 to that in 2013?
Offer a very short reply. 0.92. What is the ratio of the Balance of Payment (as % of commercial service exports) of Myanmar in 2011 to that in 2012?
Ensure brevity in your answer.  0.98. What is the ratio of the Balance of Payment (as % of commercial service exports) in Slovak Republic in 2011 to that in 2012?
Your answer should be compact. 1.14. What is the ratio of the Balance of Payment (as % of commercial service exports) in Ukraine in 2011 to that in 2012?
Offer a terse response. 0.92. What is the ratio of the Balance of Payment (as % of commercial service exports) of Myanmar in 2011 to that in 2013?
Provide a short and direct response. 1.06. What is the ratio of the Balance of Payment (as % of commercial service exports) of Slovak Republic in 2011 to that in 2013?
Offer a very short reply. 1.08. What is the ratio of the Balance of Payment (as % of commercial service exports) of Ukraine in 2011 to that in 2013?
Your response must be concise. 0.9. What is the ratio of the Balance of Payment (as % of commercial service exports) in Myanmar in 2012 to that in 2013?
Offer a terse response. 1.08. What is the ratio of the Balance of Payment (as % of commercial service exports) of Slovak Republic in 2012 to that in 2013?
Keep it short and to the point. 0.95. What is the ratio of the Balance of Payment (as % of commercial service exports) in Ukraine in 2012 to that in 2013?
Your answer should be very brief. 0.97. What is the difference between the highest and the second highest Balance of Payment (as % of commercial service exports) in Myanmar?
Provide a short and direct response. 0.8. What is the difference between the highest and the second highest Balance of Payment (as % of commercial service exports) of Slovak Republic?
Your response must be concise. 1.21. What is the difference between the highest and the second highest Balance of Payment (as % of commercial service exports) in Ukraine?
Provide a succinct answer. 0.35. What is the difference between the highest and the lowest Balance of Payment (as % of commercial service exports) of Myanmar?
Your answer should be very brief. 29.78. What is the difference between the highest and the lowest Balance of Payment (as % of commercial service exports) of Slovak Republic?
Make the answer very short. 10.17. What is the difference between the highest and the lowest Balance of Payment (as % of commercial service exports) of Ukraine?
Your answer should be compact. 10.37. 